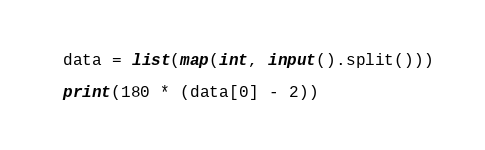Convert code to text. <code><loc_0><loc_0><loc_500><loc_500><_Python_>data = list(map(int, input().split()))

print(180 * (data[0] - 2))
</code> 